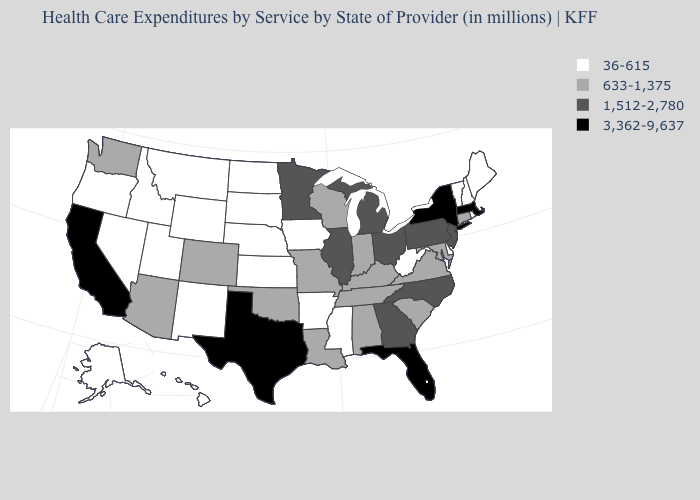Name the states that have a value in the range 633-1,375?
Concise answer only. Alabama, Arizona, Colorado, Connecticut, Indiana, Kentucky, Louisiana, Maryland, Missouri, Oklahoma, South Carolina, Tennessee, Virginia, Washington, Wisconsin. Which states have the lowest value in the South?
Concise answer only. Arkansas, Delaware, Mississippi, West Virginia. Name the states that have a value in the range 633-1,375?
Keep it brief. Alabama, Arizona, Colorado, Connecticut, Indiana, Kentucky, Louisiana, Maryland, Missouri, Oklahoma, South Carolina, Tennessee, Virginia, Washington, Wisconsin. What is the value of New Hampshire?
Give a very brief answer. 36-615. Name the states that have a value in the range 633-1,375?
Concise answer only. Alabama, Arizona, Colorado, Connecticut, Indiana, Kentucky, Louisiana, Maryland, Missouri, Oklahoma, South Carolina, Tennessee, Virginia, Washington, Wisconsin. Does California have the lowest value in the West?
Concise answer only. No. Does Arizona have the same value as California?
Answer briefly. No. What is the highest value in states that border Colorado?
Quick response, please. 633-1,375. What is the lowest value in states that border Maryland?
Answer briefly. 36-615. Does Louisiana have the same value as Iowa?
Give a very brief answer. No. Name the states that have a value in the range 633-1,375?
Give a very brief answer. Alabama, Arizona, Colorado, Connecticut, Indiana, Kentucky, Louisiana, Maryland, Missouri, Oklahoma, South Carolina, Tennessee, Virginia, Washington, Wisconsin. What is the lowest value in the USA?
Quick response, please. 36-615. What is the highest value in the USA?
Be succinct. 3,362-9,637. Which states have the lowest value in the USA?
Write a very short answer. Alaska, Arkansas, Delaware, Hawaii, Idaho, Iowa, Kansas, Maine, Mississippi, Montana, Nebraska, Nevada, New Hampshire, New Mexico, North Dakota, Oregon, Rhode Island, South Dakota, Utah, Vermont, West Virginia, Wyoming. What is the value of North Carolina?
Keep it brief. 1,512-2,780. 